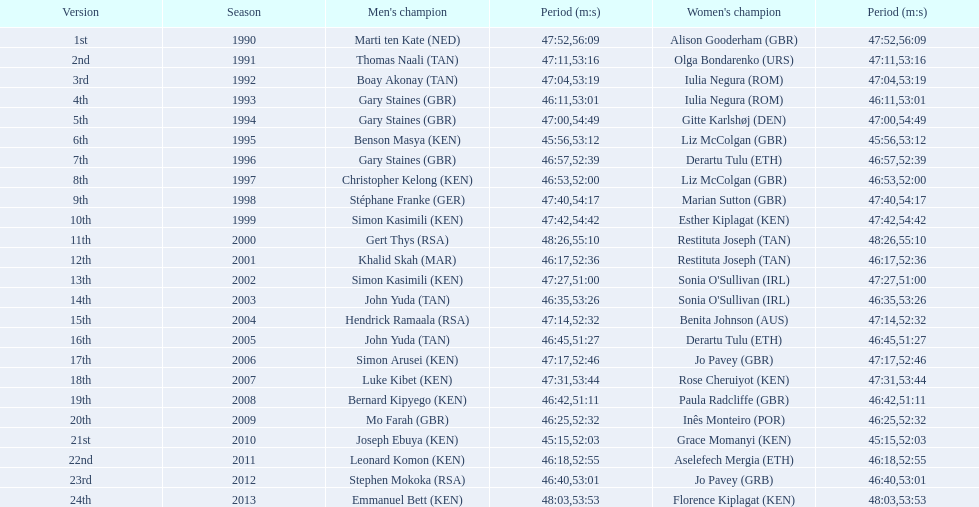What is the number of times, between 1990 and 2013, for britain not to win the men's or women's bupa great south run? 13. 